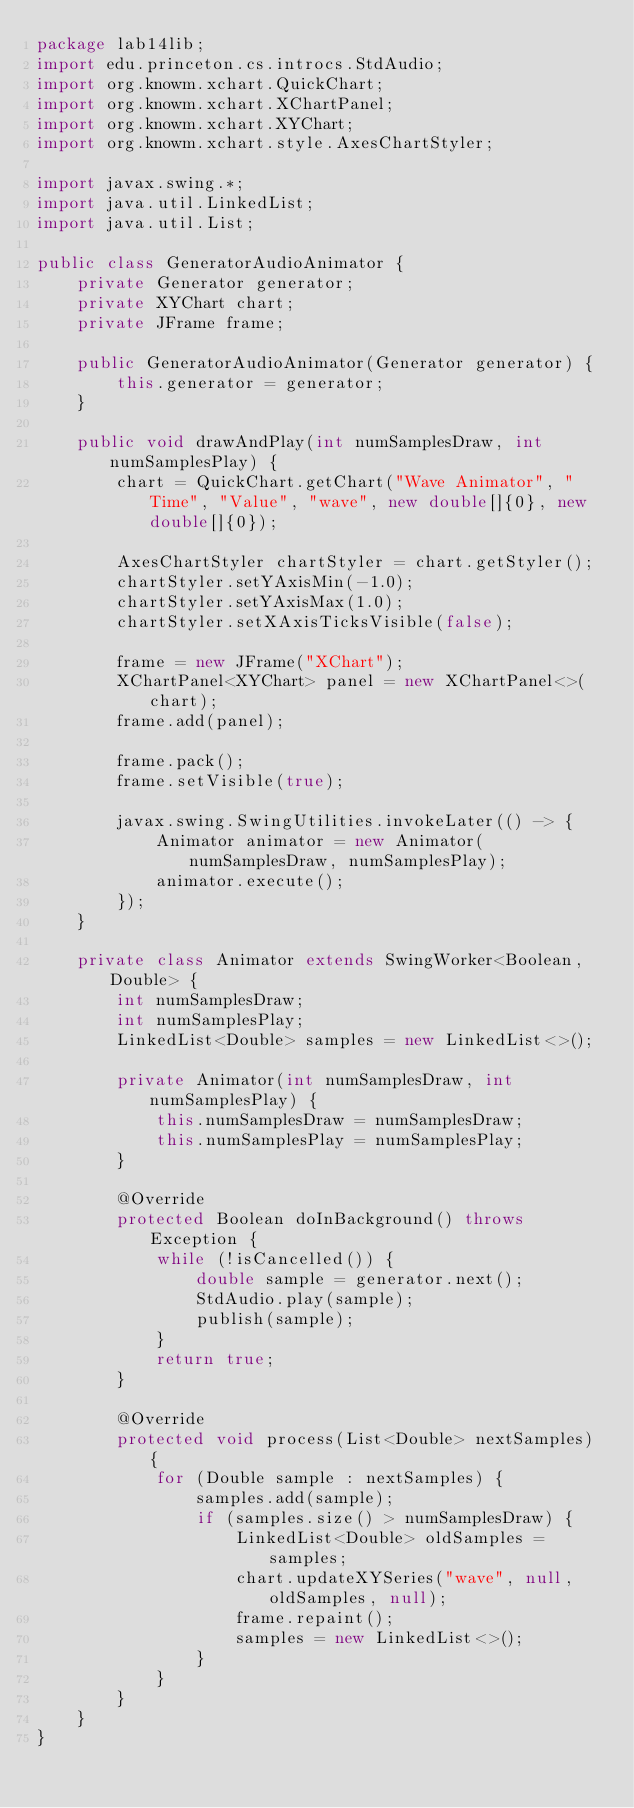Convert code to text. <code><loc_0><loc_0><loc_500><loc_500><_Java_>package lab14lib;
import edu.princeton.cs.introcs.StdAudio;
import org.knowm.xchart.QuickChart;
import org.knowm.xchart.XChartPanel;
import org.knowm.xchart.XYChart;
import org.knowm.xchart.style.AxesChartStyler;

import javax.swing.*;
import java.util.LinkedList;
import java.util.List;

public class GeneratorAudioAnimator {
    private Generator generator;
    private XYChart chart;
    private JFrame frame;

    public GeneratorAudioAnimator(Generator generator) {
        this.generator = generator;
    }

    public void drawAndPlay(int numSamplesDraw, int numSamplesPlay) {
        chart = QuickChart.getChart("Wave Animator", "Time", "Value", "wave", new double[]{0}, new double[]{0});

        AxesChartStyler chartStyler = chart.getStyler();
        chartStyler.setYAxisMin(-1.0);
        chartStyler.setYAxisMax(1.0);
        chartStyler.setXAxisTicksVisible(false);

        frame = new JFrame("XChart");
        XChartPanel<XYChart> panel = new XChartPanel<>(chart);
        frame.add(panel);

        frame.pack();
        frame.setVisible(true);

        javax.swing.SwingUtilities.invokeLater(() -> {
            Animator animator = new Animator(numSamplesDraw, numSamplesPlay);
            animator.execute();
        });
    }

    private class Animator extends SwingWorker<Boolean, Double> {
        int numSamplesDraw;
        int numSamplesPlay;
        LinkedList<Double> samples = new LinkedList<>();

        private Animator(int numSamplesDraw, int numSamplesPlay) {
            this.numSamplesDraw = numSamplesDraw;
            this.numSamplesPlay = numSamplesPlay;
        }

        @Override
        protected Boolean doInBackground() throws Exception {
            while (!isCancelled()) {
                double sample = generator.next();
                StdAudio.play(sample);
                publish(sample);
            }
            return true;
        }

        @Override
        protected void process(List<Double> nextSamples) {
            for (Double sample : nextSamples) {
                samples.add(sample);
                if (samples.size() > numSamplesDraw) {
                    LinkedList<Double> oldSamples = samples;
                    chart.updateXYSeries("wave", null, oldSamples, null);
                    frame.repaint();
                    samples = new LinkedList<>();
                }
            }
        }
    }
}
</code> 